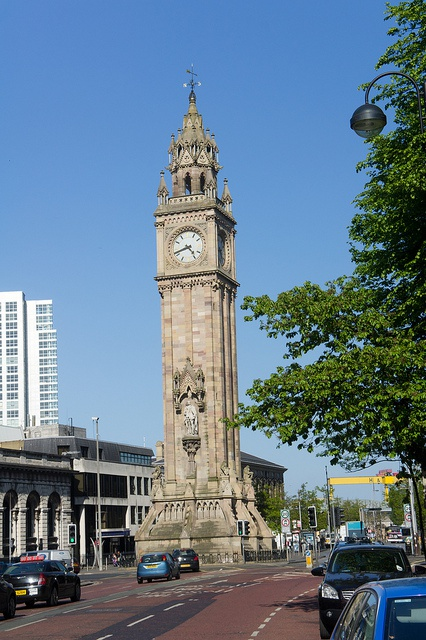Describe the objects in this image and their specific colors. I can see car in gray, black, navy, and blue tones, car in gray, black, navy, and blue tones, car in gray, black, navy, and blue tones, car in gray, black, and blue tones, and clock in gray, lightgray, darkgray, and beige tones in this image. 